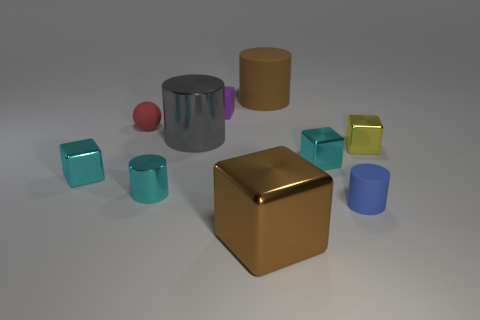Does the brown thing in front of the red object have the same shape as the metallic object that is on the left side of the rubber sphere?
Give a very brief answer. Yes. Are there any cyan balls made of the same material as the big cube?
Your response must be concise. No. There is a big metal object that is behind the blue object that is behind the brown metallic object in front of the gray thing; what is its color?
Your answer should be compact. Gray. Do the tiny cyan object that is on the right side of the brown metal cube and the big cylinder on the right side of the small purple object have the same material?
Provide a succinct answer. No. What is the shape of the small cyan metal object that is on the left side of the tiny red object?
Keep it short and to the point. Cube. How many objects are cylinders or metallic things that are to the right of the red rubber sphere?
Give a very brief answer. 7. Are the small red sphere and the tiny purple object made of the same material?
Your response must be concise. Yes. Is the number of blue matte cylinders in front of the small purple rubber cube the same as the number of cyan cylinders that are on the left side of the red matte sphere?
Offer a terse response. No. What number of red objects are on the left side of the big block?
Provide a succinct answer. 1. What number of objects are blue metal spheres or tiny rubber things?
Offer a very short reply. 3. 